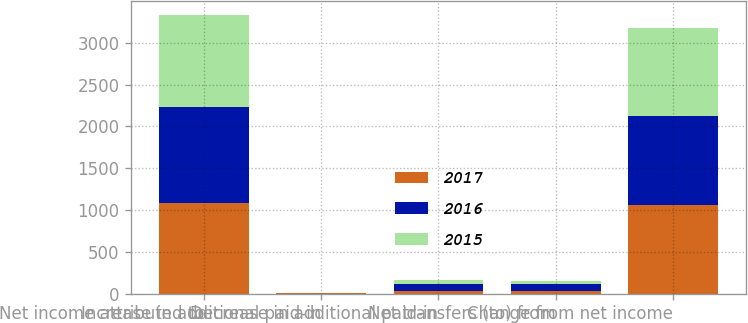<chart> <loc_0><loc_0><loc_500><loc_500><stacked_bar_chart><ecel><fcel>Net income attributed to<fcel>Increase in additional paid-in<fcel>Decrease in additional paid-in<fcel>Net transfers (to) from<fcel>Change from net income<nl><fcel>2017<fcel>1088.4<fcel>1.8<fcel>27.5<fcel>25.7<fcel>1062.7<nl><fcel>2016<fcel>1148.6<fcel>2<fcel>89.7<fcel>87.7<fcel>1060.9<nl><fcel>2015<fcel>1093.9<fcel>1.7<fcel>40.5<fcel>38.8<fcel>1055.1<nl></chart> 